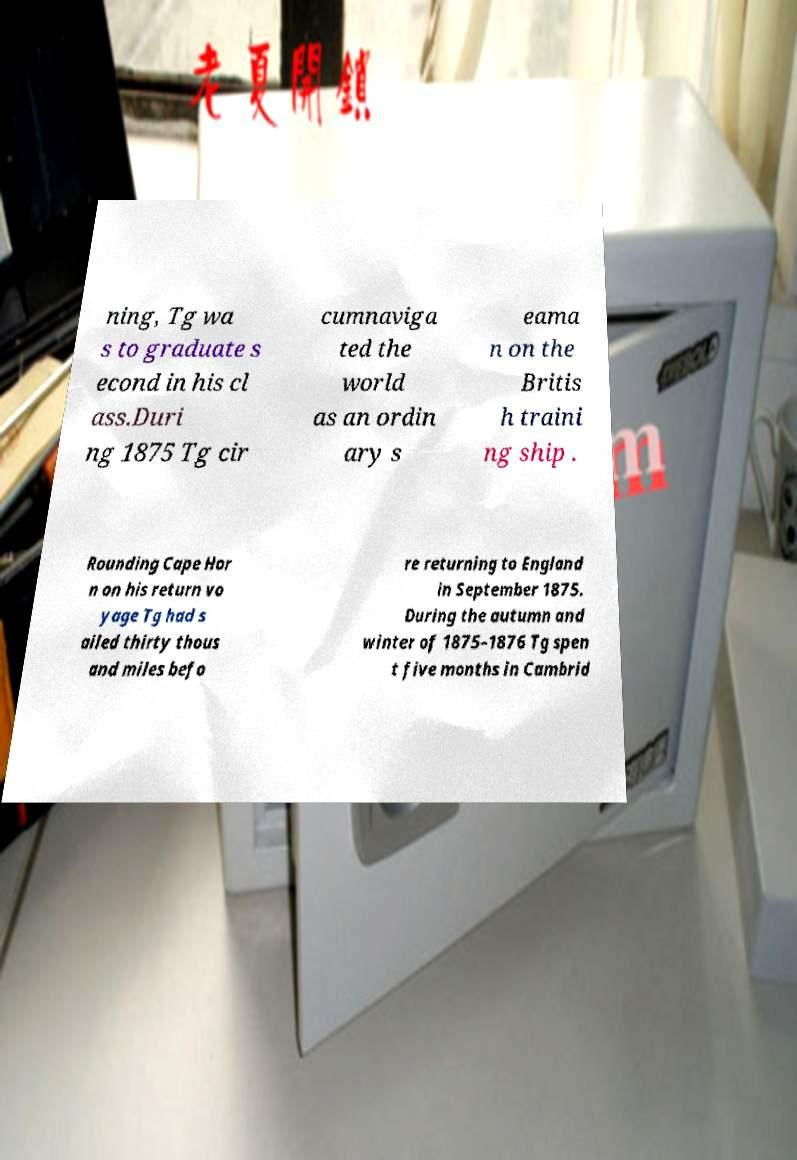Can you accurately transcribe the text from the provided image for me? ning, Tg wa s to graduate s econd in his cl ass.Duri ng 1875 Tg cir cumnaviga ted the world as an ordin ary s eama n on the Britis h traini ng ship . Rounding Cape Hor n on his return vo yage Tg had s ailed thirty thous and miles befo re returning to England in September 1875. During the autumn and winter of 1875–1876 Tg spen t five months in Cambrid 